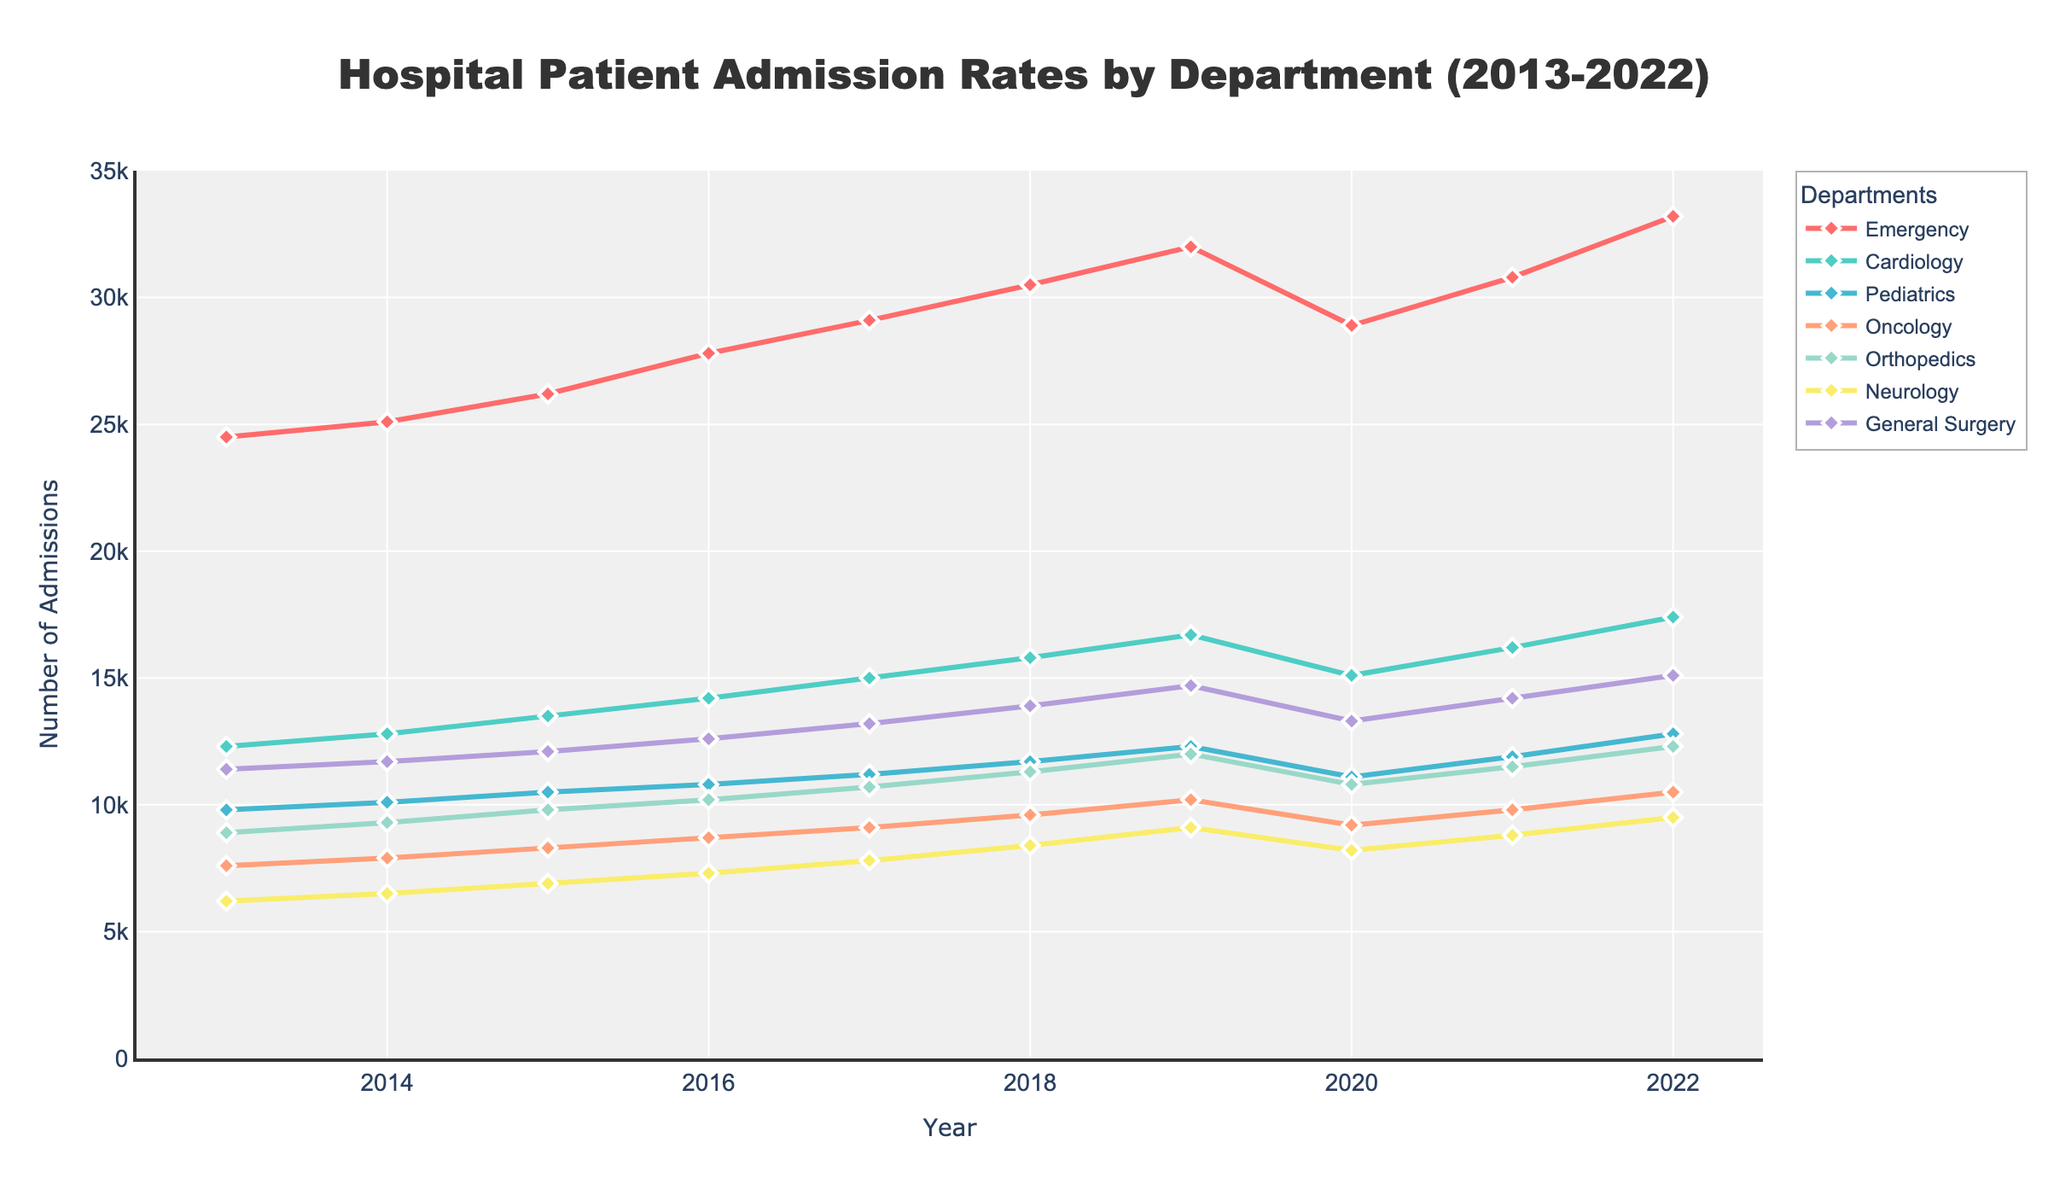What is the overall trend in patient admissions for the Emergency department from 2013 to 2022? Observing the line plot, the Emergency department shows a general upward trend over the decade, albeit with a dip in 2020. Starting around 24,500 in 2013 and rising to approximately 33,200 by 2022.
Answer: Upward trend In which year did the oncology department have the highest number of patient admissions? The highest point of the Oncology department line can be observed in 2022, where the admissions reached approximately 10,500.
Answer: 2022 How do the admission trends for Pediatrics and Orthopedics departments compare between 2013 and 2022? Both departments show an upward trend from 2013 to 2022. Pediatrics starts at approximately 9,800 in 2013 and increases to about 12,800 by 2022, while Orthopedics begins around 8,900 and rises to approximately 12,300.
Answer: Both increased Which department experienced a decrease in patient admissions in 2020? The line for the Emergency department experienced a noticeable drop in 2020, where admissions fell to around 28,900, down from the previous year.
Answer: Emergency How do the admission rates for General Surgery compare to Neurology over the decade? General Surgery consistently has higher admission rates than Neurology. Starting around 11,400 in 2013 and reaching approximately 15,100 in 2022. In contrast, Neurology starts at approximately 6,200 and rises to about 9,500 during the same period.
Answer: General Surgery higher Calculate the average annual increase in patient admissions for the Cardiology department from 2013 to 2022. The admissions for Cardiology start at 12,300 in 2013 and rise to 17,400 by 2022. The difference is 17,400 - 12,300 = 5,100. Dividing by the number of years (2022-2013 = 9), the average annual increase is 5,100 / 9 = 566.67.
Answer: 566.67 What was the difference in admission numbers between Neurology and Pediatrics departments in 2019? In 2019, the line for Neurology indicates approximately 9,100 admissions, while Pediatrics shows about 12,300 admissions. The difference is 12,300 - 9,100 = 3,200.
Answer: 3,200 Which department had the smallest overall increase in patient admissions from 2013 to 2022? By comparing the starting and ending points of each line, Neurology experienced the smallest increase. It starts at approximately 6,200 in 2013 and ends at around 9,500 in 2022, an increase of 3,300.
Answer: Neurology What is the combined total number of admissions in 2022 for Oncology and Emergency departments? The admissions for Oncology in 2022 are approximately 10,500 and for Emergency are about 33,200. The combined total is 10,500 + 33,200 = 43,700.
Answer: 43,700 